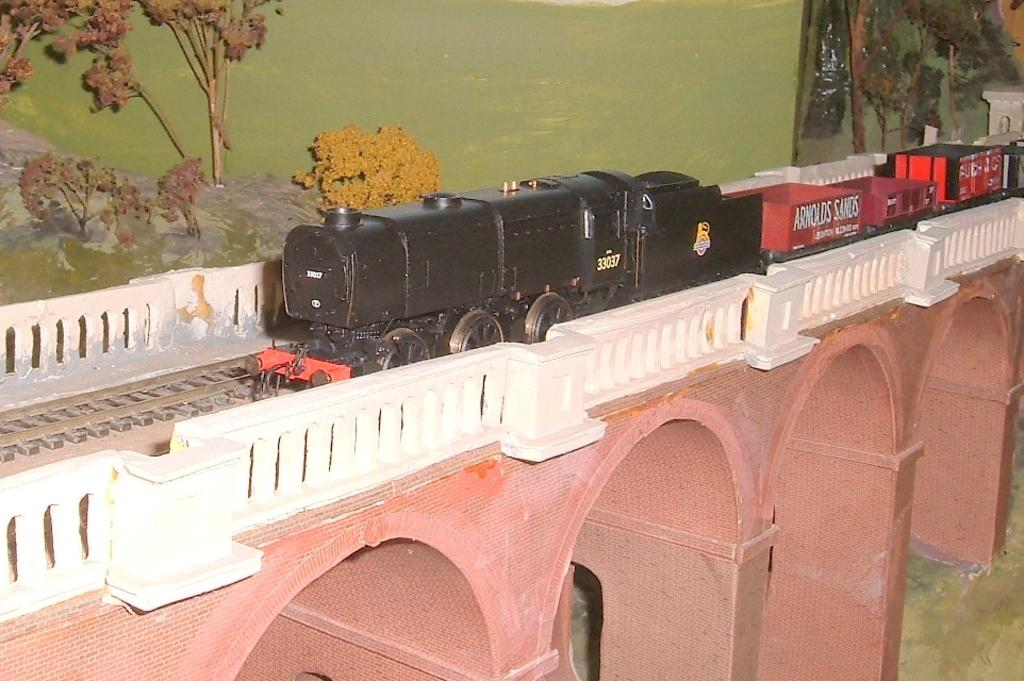What is the main subject of the image? The main subject of the image is a toy train. Can you describe the train's position in the image? The toy train is on a track. What is the track situated on? The track is on a bridge. What can be seen in the background of the image? There are trees in the background of the image. What committee is responsible for maintaining the toy train in the image? There is no committee mentioned or implied in the image, as it is a toy train and not a real train. 